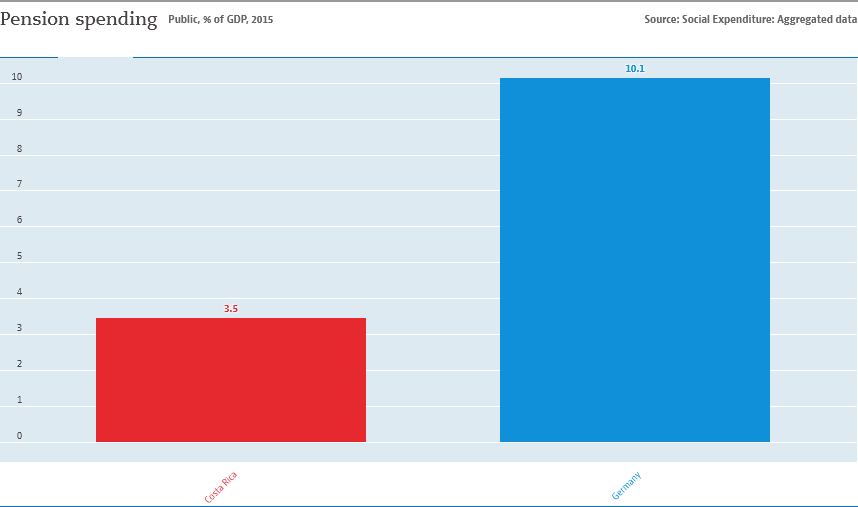Specify some key components in this picture. The pension spending value difference between Germany and Costa Rica is greater than 5. According to the data, the country with the highest value of pension spenders is Germany, followed by Costa Rica. 